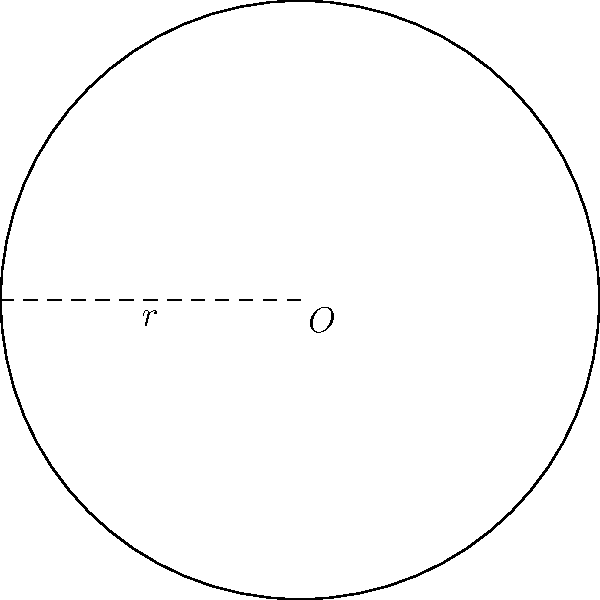As a food critic, you're presented with an exquisite circular plate at a Michelin-starred restaurant. The chef mentions that the plate has a radius of 12 inches. Calculate the area of this circular plate, rounding your answer to the nearest square inch. To calculate the area of a circular plate, we'll follow these steps:

1) The formula for the area of a circle is $A = \pi r^2$, where $r$ is the radius.

2) We're given that the radius is 12 inches.

3) Let's substitute this into our formula:
   $A = \pi (12)^2$

4) Simplify the exponent:
   $A = \pi (144)$

5) Multiply:
   $A = 452.3893...$ square inches

6) Rounding to the nearest square inch:
   $A \approx 452$ square inches

This large plate size is perfect for presenting elaborate, visually stunning dishes that you often encounter in your food critic role.
Answer: 452 square inches 